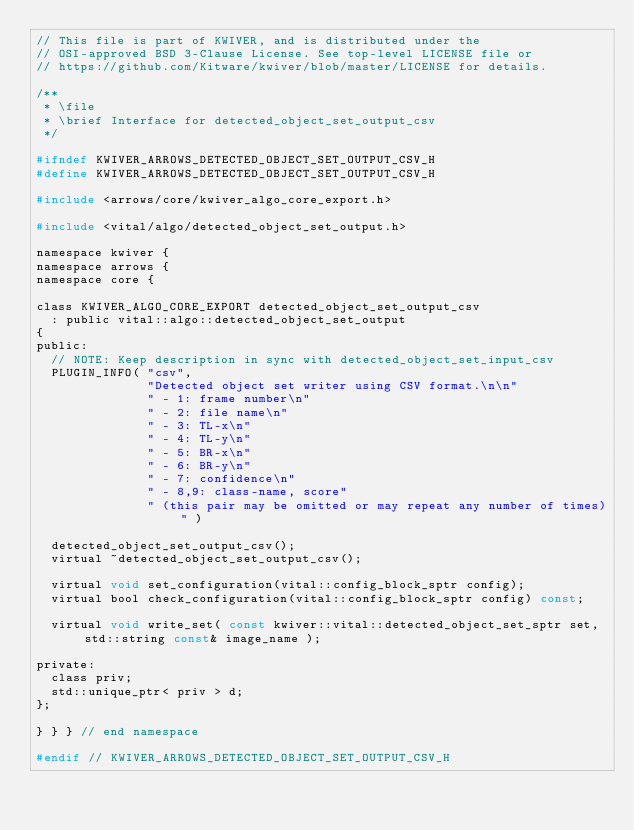<code> <loc_0><loc_0><loc_500><loc_500><_C_>// This file is part of KWIVER, and is distributed under the
// OSI-approved BSD 3-Clause License. See top-level LICENSE file or
// https://github.com/Kitware/kwiver/blob/master/LICENSE for details.

/**
 * \file
 * \brief Interface for detected_object_set_output_csv
 */

#ifndef KWIVER_ARROWS_DETECTED_OBJECT_SET_OUTPUT_CSV_H
#define KWIVER_ARROWS_DETECTED_OBJECT_SET_OUTPUT_CSV_H

#include <arrows/core/kwiver_algo_core_export.h>

#include <vital/algo/detected_object_set_output.h>

namespace kwiver {
namespace arrows {
namespace core {

class KWIVER_ALGO_CORE_EXPORT detected_object_set_output_csv
  : public vital::algo::detected_object_set_output
{
public:
  // NOTE: Keep description in sync with detected_object_set_input_csv
  PLUGIN_INFO( "csv",
               "Detected object set writer using CSV format.\n\n"
               " - 1: frame number\n"
               " - 2: file name\n"
               " - 3: TL-x\n"
               " - 4: TL-y\n"
               " - 5: BR-x\n"
               " - 6: BR-y\n"
               " - 7: confidence\n"
               " - 8,9: class-name, score"
               " (this pair may be omitted or may repeat any number of times)" )

  detected_object_set_output_csv();
  virtual ~detected_object_set_output_csv();

  virtual void set_configuration(vital::config_block_sptr config);
  virtual bool check_configuration(vital::config_block_sptr config) const;

  virtual void write_set( const kwiver::vital::detected_object_set_sptr set, std::string const& image_name );

private:
  class priv;
  std::unique_ptr< priv > d;
};

} } } // end namespace

#endif // KWIVER_ARROWS_DETECTED_OBJECT_SET_OUTPUT_CSV_H
</code> 